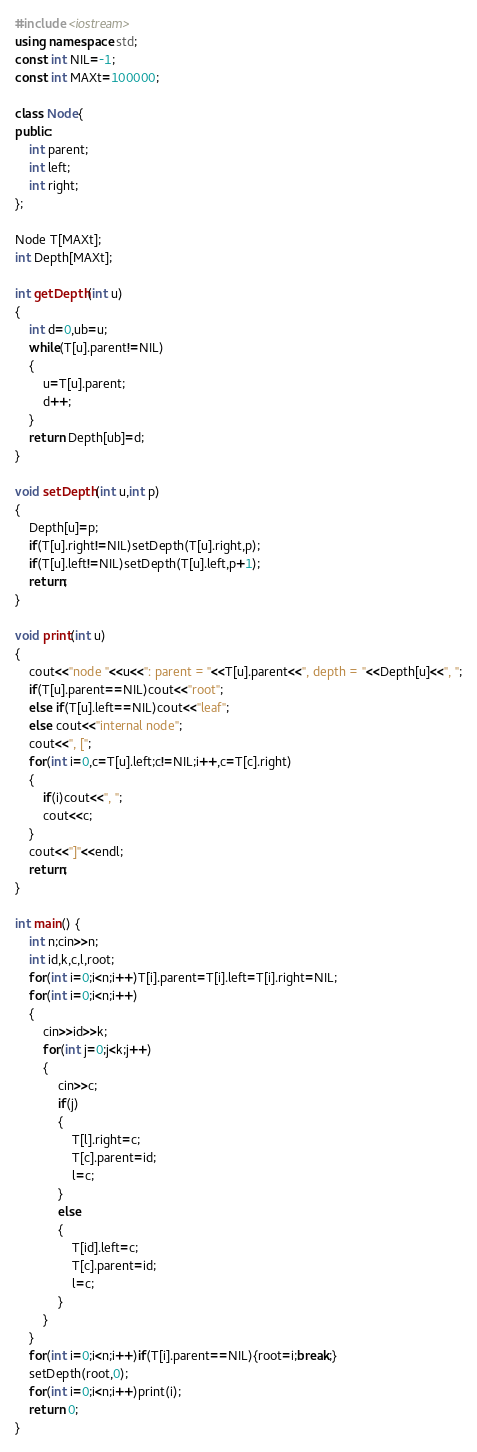<code> <loc_0><loc_0><loc_500><loc_500><_C++_>#include <iostream>
using namespace std;
const int NIL=-1;
const int MAXt=100000;

class Node{
public:
	int parent;
	int left;
	int right;
};

Node T[MAXt];
int Depth[MAXt];

int getDepth(int u)
{
	int d=0,ub=u;
	while(T[u].parent!=NIL)
	{
		u=T[u].parent;
		d++;
	}
	return Depth[ub]=d;
}

void setDepth(int u,int p)
{
	Depth[u]=p;
	if(T[u].right!=NIL)setDepth(T[u].right,p);
	if(T[u].left!=NIL)setDepth(T[u].left,p+1);
	return;
}

void print(int u)
{
	cout<<"node "<<u<<": parent = "<<T[u].parent<<", depth = "<<Depth[u]<<", ";
	if(T[u].parent==NIL)cout<<"root";
	else if(T[u].left==NIL)cout<<"leaf";
	else cout<<"internal node";
	cout<<", [";
	for(int i=0,c=T[u].left;c!=NIL;i++,c=T[c].right)
	{
		if(i)cout<<", ";
		cout<<c;
	}
	cout<<"]"<<endl;
	return;
}

int main() {
	int n;cin>>n;
	int id,k,c,l,root;
	for(int i=0;i<n;i++)T[i].parent=T[i].left=T[i].right=NIL;
	for(int i=0;i<n;i++)
	{
		cin>>id>>k;
		for(int j=0;j<k;j++)
		{
			cin>>c;
			if(j)
			{
				T[l].right=c;
				T[c].parent=id;
				l=c;
			}
			else
			{
				T[id].left=c;
				T[c].parent=id;
				l=c;
			}
		}
	}
	for(int i=0;i<n;i++)if(T[i].parent==NIL){root=i;break;}
	setDepth(root,0);
	for(int i=0;i<n;i++)print(i);
	return 0;
}</code> 